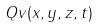Convert formula to latex. <formula><loc_0><loc_0><loc_500><loc_500>Q v ( x , y , z , t )</formula> 